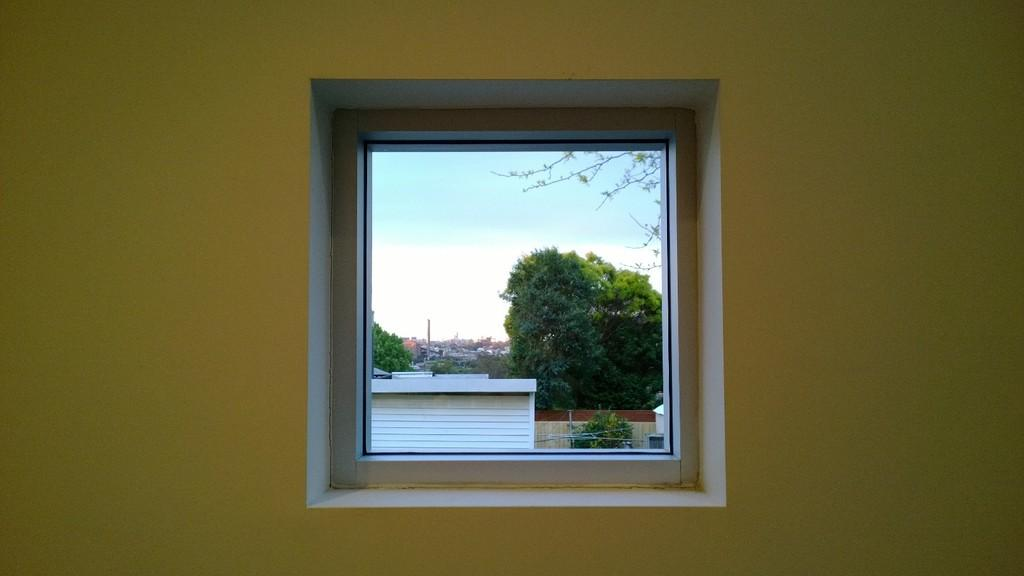What architectural feature is present in the wall of the image? There is a window in the wall of the image. What can be seen in the background of the image? There are buildings and trees in the background of the image. What part of the natural environment is visible in the image? The sky is visible in the background of the image. What type of question can be seen crawling on the window in the image? There is no question or snail present in the image; it features a window in the wall. What is the pail used for in the image? There is no pail present in the image. 